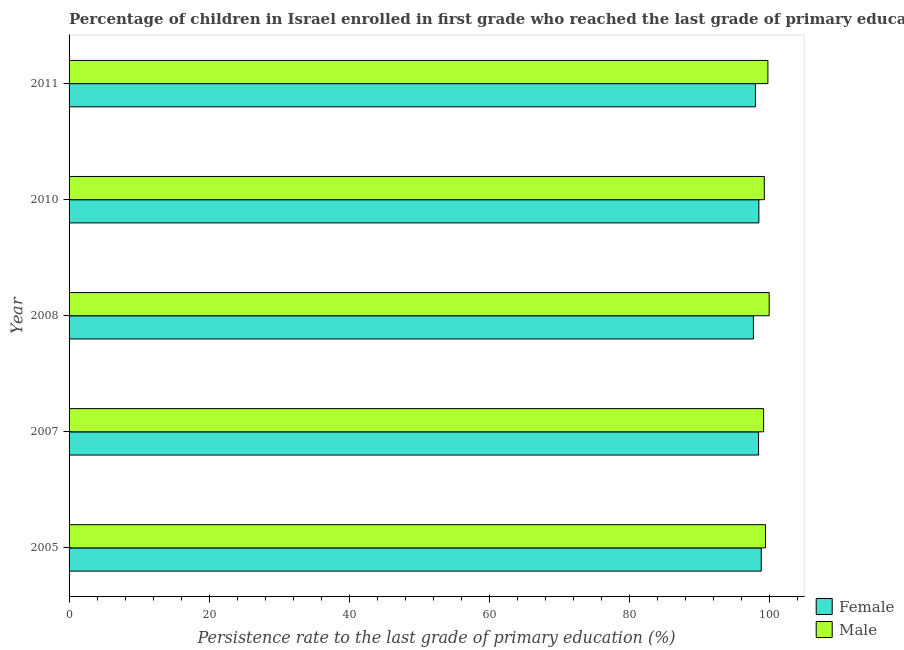How many different coloured bars are there?
Offer a very short reply. 2. How many groups of bars are there?
Provide a short and direct response. 5. Are the number of bars on each tick of the Y-axis equal?
Keep it short and to the point. Yes. What is the label of the 5th group of bars from the top?
Ensure brevity in your answer.  2005. What is the persistence rate of male students in 2011?
Make the answer very short. 99.82. Across all years, what is the maximum persistence rate of female students?
Provide a succinct answer. 98.87. Across all years, what is the minimum persistence rate of male students?
Keep it short and to the point. 99.2. In which year was the persistence rate of female students maximum?
Ensure brevity in your answer.  2005. What is the total persistence rate of male students in the graph?
Ensure brevity in your answer.  497.79. What is the difference between the persistence rate of male students in 2005 and that in 2011?
Provide a short and direct response. -0.35. What is the difference between the persistence rate of male students in 2005 and the persistence rate of female students in 2011?
Provide a succinct answer. 1.43. What is the average persistence rate of male students per year?
Your response must be concise. 99.56. In the year 2010, what is the difference between the persistence rate of female students and persistence rate of male students?
Provide a short and direct response. -0.78. In how many years, is the persistence rate of male students greater than 20 %?
Keep it short and to the point. 5. Is the persistence rate of female students in 2008 less than that in 2010?
Provide a short and direct response. Yes. Is the difference between the persistence rate of female students in 2007 and 2011 greater than the difference between the persistence rate of male students in 2007 and 2011?
Provide a short and direct response. Yes. What is the difference between the highest and the second highest persistence rate of female students?
Provide a succinct answer. 0.34. What is the difference between the highest and the lowest persistence rate of female students?
Keep it short and to the point. 1.12. Is the sum of the persistence rate of female students in 2007 and 2010 greater than the maximum persistence rate of male students across all years?
Provide a short and direct response. Yes. What does the 2nd bar from the top in 2007 represents?
Offer a very short reply. Female. What does the 2nd bar from the bottom in 2010 represents?
Offer a very short reply. Male. Are all the bars in the graph horizontal?
Ensure brevity in your answer.  Yes. What is the difference between two consecutive major ticks on the X-axis?
Ensure brevity in your answer.  20. Are the values on the major ticks of X-axis written in scientific E-notation?
Your answer should be compact. No. Does the graph contain grids?
Your response must be concise. No. Where does the legend appear in the graph?
Provide a short and direct response. Bottom right. How many legend labels are there?
Make the answer very short. 2. What is the title of the graph?
Your answer should be very brief. Percentage of children in Israel enrolled in first grade who reached the last grade of primary education. Does "Primary" appear as one of the legend labels in the graph?
Offer a terse response. No. What is the label or title of the X-axis?
Your answer should be compact. Persistence rate to the last grade of primary education (%). What is the label or title of the Y-axis?
Provide a succinct answer. Year. What is the Persistence rate to the last grade of primary education (%) in Female in 2005?
Offer a very short reply. 98.87. What is the Persistence rate to the last grade of primary education (%) of Male in 2005?
Provide a short and direct response. 99.47. What is the Persistence rate to the last grade of primary education (%) in Female in 2007?
Your response must be concise. 98.48. What is the Persistence rate to the last grade of primary education (%) in Male in 2007?
Provide a short and direct response. 99.2. What is the Persistence rate to the last grade of primary education (%) of Female in 2008?
Provide a short and direct response. 97.74. What is the Persistence rate to the last grade of primary education (%) in Female in 2010?
Offer a terse response. 98.53. What is the Persistence rate to the last grade of primary education (%) in Male in 2010?
Your answer should be very brief. 99.3. What is the Persistence rate to the last grade of primary education (%) of Female in 2011?
Give a very brief answer. 98.04. What is the Persistence rate to the last grade of primary education (%) of Male in 2011?
Your response must be concise. 99.82. Across all years, what is the maximum Persistence rate to the last grade of primary education (%) of Female?
Keep it short and to the point. 98.87. Across all years, what is the maximum Persistence rate to the last grade of primary education (%) of Male?
Offer a terse response. 100. Across all years, what is the minimum Persistence rate to the last grade of primary education (%) of Female?
Offer a terse response. 97.74. Across all years, what is the minimum Persistence rate to the last grade of primary education (%) of Male?
Give a very brief answer. 99.2. What is the total Persistence rate to the last grade of primary education (%) of Female in the graph?
Offer a very short reply. 491.65. What is the total Persistence rate to the last grade of primary education (%) in Male in the graph?
Provide a succinct answer. 497.79. What is the difference between the Persistence rate to the last grade of primary education (%) in Female in 2005 and that in 2007?
Provide a short and direct response. 0.39. What is the difference between the Persistence rate to the last grade of primary education (%) in Male in 2005 and that in 2007?
Offer a terse response. 0.27. What is the difference between the Persistence rate to the last grade of primary education (%) of Female in 2005 and that in 2008?
Provide a succinct answer. 1.12. What is the difference between the Persistence rate to the last grade of primary education (%) in Male in 2005 and that in 2008?
Your answer should be very brief. -0.53. What is the difference between the Persistence rate to the last grade of primary education (%) in Female in 2005 and that in 2010?
Keep it short and to the point. 0.34. What is the difference between the Persistence rate to the last grade of primary education (%) of Male in 2005 and that in 2010?
Give a very brief answer. 0.17. What is the difference between the Persistence rate to the last grade of primary education (%) in Female in 2005 and that in 2011?
Your answer should be compact. 0.83. What is the difference between the Persistence rate to the last grade of primary education (%) of Male in 2005 and that in 2011?
Offer a terse response. -0.35. What is the difference between the Persistence rate to the last grade of primary education (%) in Female in 2007 and that in 2008?
Provide a short and direct response. 0.74. What is the difference between the Persistence rate to the last grade of primary education (%) in Male in 2007 and that in 2008?
Your response must be concise. -0.8. What is the difference between the Persistence rate to the last grade of primary education (%) in Female in 2007 and that in 2010?
Your answer should be very brief. -0.05. What is the difference between the Persistence rate to the last grade of primary education (%) in Male in 2007 and that in 2010?
Offer a terse response. -0.1. What is the difference between the Persistence rate to the last grade of primary education (%) of Female in 2007 and that in 2011?
Your response must be concise. 0.44. What is the difference between the Persistence rate to the last grade of primary education (%) in Male in 2007 and that in 2011?
Provide a short and direct response. -0.61. What is the difference between the Persistence rate to the last grade of primary education (%) in Female in 2008 and that in 2010?
Ensure brevity in your answer.  -0.78. What is the difference between the Persistence rate to the last grade of primary education (%) of Male in 2008 and that in 2010?
Offer a terse response. 0.7. What is the difference between the Persistence rate to the last grade of primary education (%) of Female in 2008 and that in 2011?
Your response must be concise. -0.29. What is the difference between the Persistence rate to the last grade of primary education (%) in Male in 2008 and that in 2011?
Provide a short and direct response. 0.18. What is the difference between the Persistence rate to the last grade of primary education (%) in Female in 2010 and that in 2011?
Give a very brief answer. 0.49. What is the difference between the Persistence rate to the last grade of primary education (%) in Male in 2010 and that in 2011?
Make the answer very short. -0.52. What is the difference between the Persistence rate to the last grade of primary education (%) in Female in 2005 and the Persistence rate to the last grade of primary education (%) in Male in 2007?
Give a very brief answer. -0.34. What is the difference between the Persistence rate to the last grade of primary education (%) in Female in 2005 and the Persistence rate to the last grade of primary education (%) in Male in 2008?
Your answer should be very brief. -1.13. What is the difference between the Persistence rate to the last grade of primary education (%) in Female in 2005 and the Persistence rate to the last grade of primary education (%) in Male in 2010?
Your answer should be compact. -0.43. What is the difference between the Persistence rate to the last grade of primary education (%) of Female in 2005 and the Persistence rate to the last grade of primary education (%) of Male in 2011?
Provide a succinct answer. -0.95. What is the difference between the Persistence rate to the last grade of primary education (%) of Female in 2007 and the Persistence rate to the last grade of primary education (%) of Male in 2008?
Ensure brevity in your answer.  -1.52. What is the difference between the Persistence rate to the last grade of primary education (%) in Female in 2007 and the Persistence rate to the last grade of primary education (%) in Male in 2010?
Give a very brief answer. -0.82. What is the difference between the Persistence rate to the last grade of primary education (%) in Female in 2007 and the Persistence rate to the last grade of primary education (%) in Male in 2011?
Your answer should be very brief. -1.34. What is the difference between the Persistence rate to the last grade of primary education (%) of Female in 2008 and the Persistence rate to the last grade of primary education (%) of Male in 2010?
Offer a very short reply. -1.56. What is the difference between the Persistence rate to the last grade of primary education (%) of Female in 2008 and the Persistence rate to the last grade of primary education (%) of Male in 2011?
Your response must be concise. -2.07. What is the difference between the Persistence rate to the last grade of primary education (%) in Female in 2010 and the Persistence rate to the last grade of primary education (%) in Male in 2011?
Your answer should be compact. -1.29. What is the average Persistence rate to the last grade of primary education (%) in Female per year?
Ensure brevity in your answer.  98.33. What is the average Persistence rate to the last grade of primary education (%) of Male per year?
Provide a short and direct response. 99.56. In the year 2005, what is the difference between the Persistence rate to the last grade of primary education (%) of Female and Persistence rate to the last grade of primary education (%) of Male?
Your answer should be very brief. -0.6. In the year 2007, what is the difference between the Persistence rate to the last grade of primary education (%) of Female and Persistence rate to the last grade of primary education (%) of Male?
Give a very brief answer. -0.72. In the year 2008, what is the difference between the Persistence rate to the last grade of primary education (%) in Female and Persistence rate to the last grade of primary education (%) in Male?
Provide a short and direct response. -2.26. In the year 2010, what is the difference between the Persistence rate to the last grade of primary education (%) in Female and Persistence rate to the last grade of primary education (%) in Male?
Give a very brief answer. -0.78. In the year 2011, what is the difference between the Persistence rate to the last grade of primary education (%) in Female and Persistence rate to the last grade of primary education (%) in Male?
Your response must be concise. -1.78. What is the ratio of the Persistence rate to the last grade of primary education (%) in Female in 2005 to that in 2007?
Keep it short and to the point. 1. What is the ratio of the Persistence rate to the last grade of primary education (%) in Male in 2005 to that in 2007?
Keep it short and to the point. 1. What is the ratio of the Persistence rate to the last grade of primary education (%) of Female in 2005 to that in 2008?
Your answer should be very brief. 1.01. What is the ratio of the Persistence rate to the last grade of primary education (%) of Male in 2005 to that in 2008?
Give a very brief answer. 0.99. What is the ratio of the Persistence rate to the last grade of primary education (%) of Female in 2005 to that in 2011?
Provide a succinct answer. 1.01. What is the ratio of the Persistence rate to the last grade of primary education (%) in Female in 2007 to that in 2008?
Provide a short and direct response. 1.01. What is the ratio of the Persistence rate to the last grade of primary education (%) of Male in 2007 to that in 2008?
Provide a succinct answer. 0.99. What is the ratio of the Persistence rate to the last grade of primary education (%) of Male in 2007 to that in 2010?
Make the answer very short. 1. What is the ratio of the Persistence rate to the last grade of primary education (%) in Male in 2007 to that in 2011?
Provide a short and direct response. 0.99. What is the ratio of the Persistence rate to the last grade of primary education (%) of Female in 2008 to that in 2010?
Make the answer very short. 0.99. What is the ratio of the Persistence rate to the last grade of primary education (%) of Female in 2008 to that in 2011?
Ensure brevity in your answer.  1. What is the ratio of the Persistence rate to the last grade of primary education (%) of Male in 2008 to that in 2011?
Make the answer very short. 1. What is the ratio of the Persistence rate to the last grade of primary education (%) in Female in 2010 to that in 2011?
Keep it short and to the point. 1. What is the ratio of the Persistence rate to the last grade of primary education (%) of Male in 2010 to that in 2011?
Ensure brevity in your answer.  0.99. What is the difference between the highest and the second highest Persistence rate to the last grade of primary education (%) of Female?
Your response must be concise. 0.34. What is the difference between the highest and the second highest Persistence rate to the last grade of primary education (%) of Male?
Your answer should be compact. 0.18. What is the difference between the highest and the lowest Persistence rate to the last grade of primary education (%) in Female?
Provide a succinct answer. 1.12. What is the difference between the highest and the lowest Persistence rate to the last grade of primary education (%) in Male?
Your answer should be compact. 0.8. 